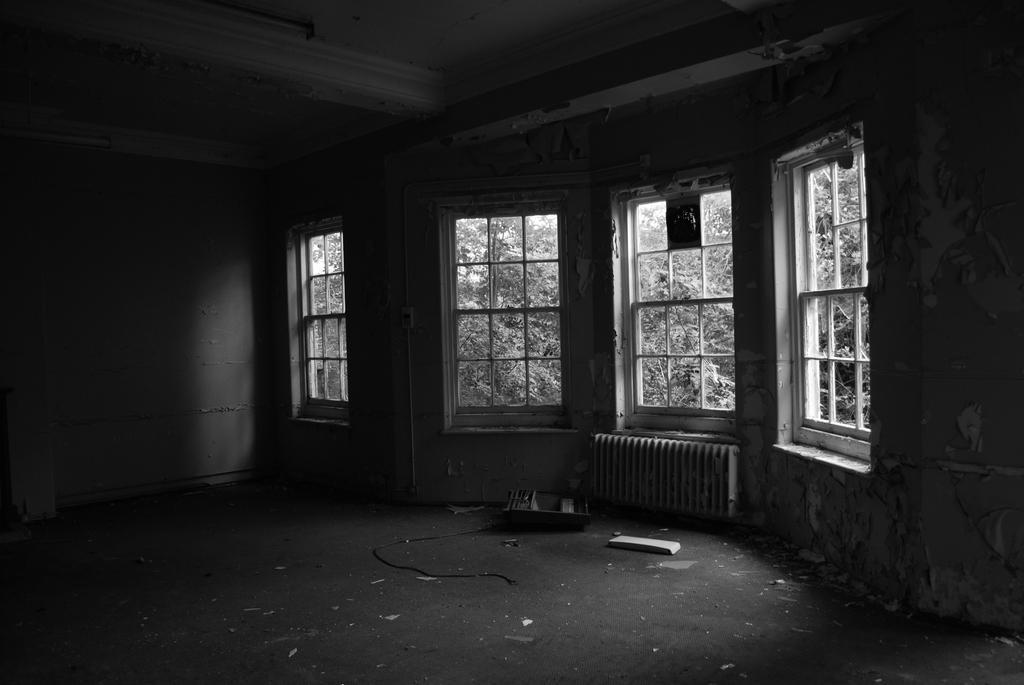In one or two sentences, can you explain what this image depicts? In this picture I can see the room. In the center I can see four windows. Through the windows I can see many trees. On the floor I can see some box and plastic objects. 